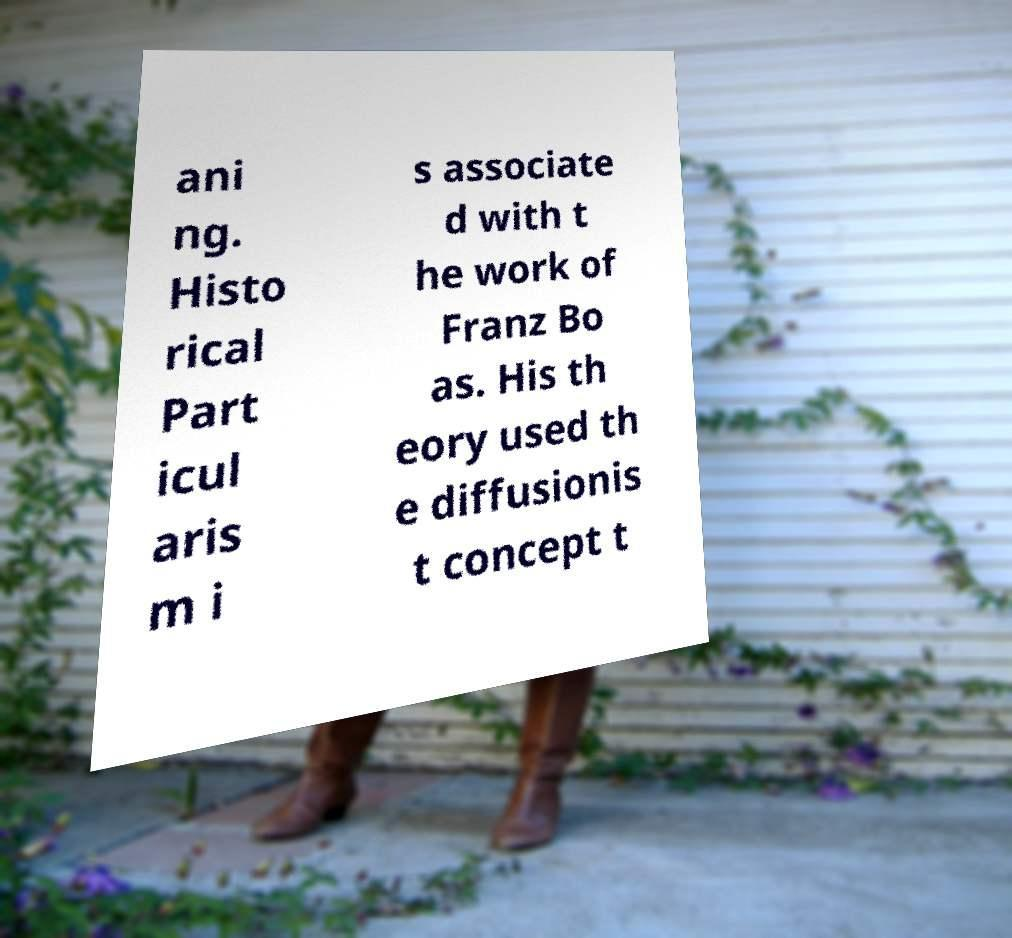Could you assist in decoding the text presented in this image and type it out clearly? ani ng. Histo rical Part icul aris m i s associate d with t he work of Franz Bo as. His th eory used th e diffusionis t concept t 